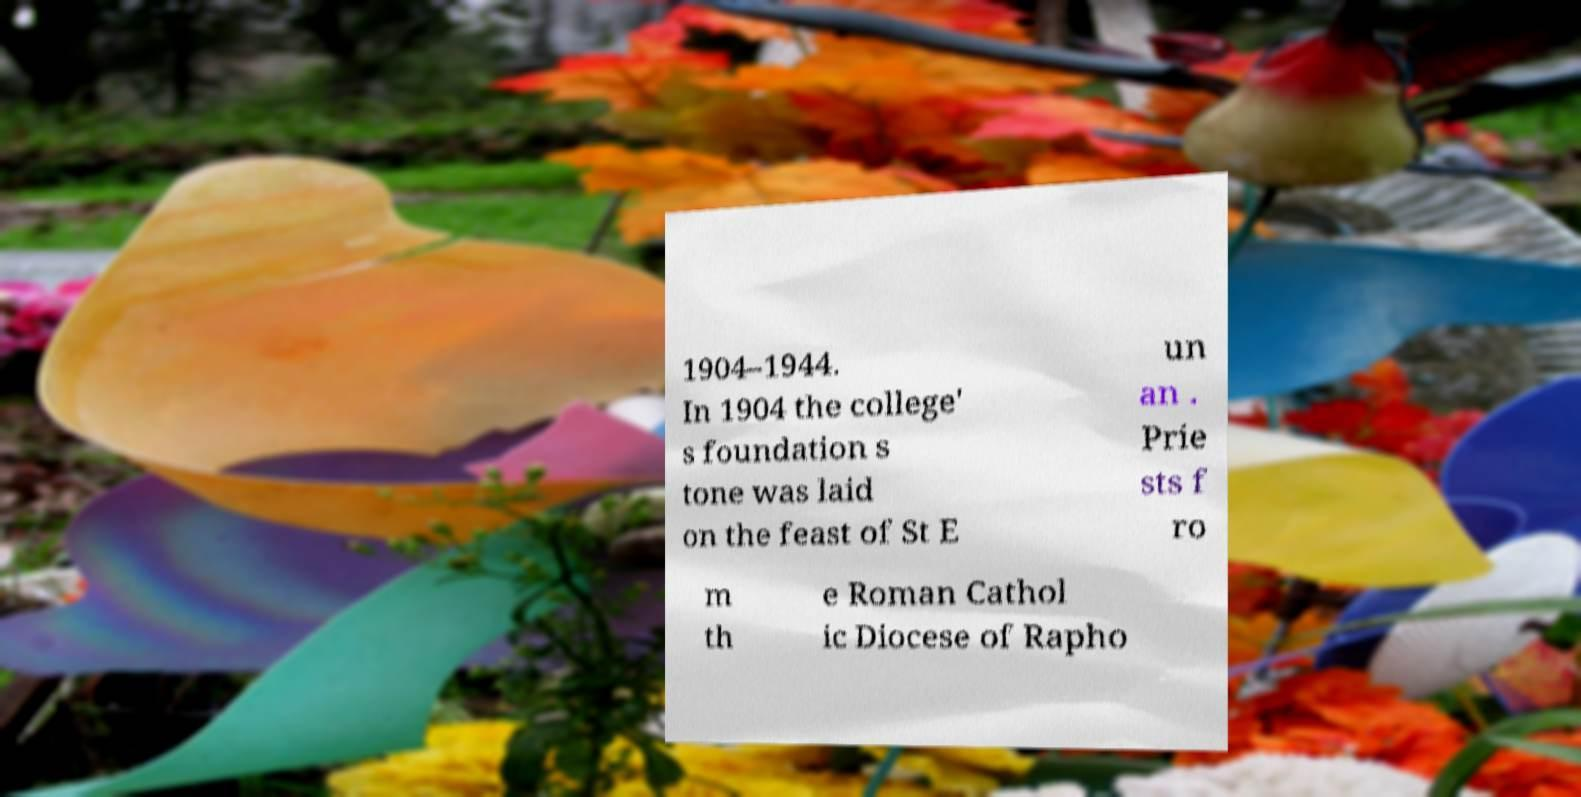For documentation purposes, I need the text within this image transcribed. Could you provide that? 1904–1944. In 1904 the college' s foundation s tone was laid on the feast of St E un an . Prie sts f ro m th e Roman Cathol ic Diocese of Rapho 